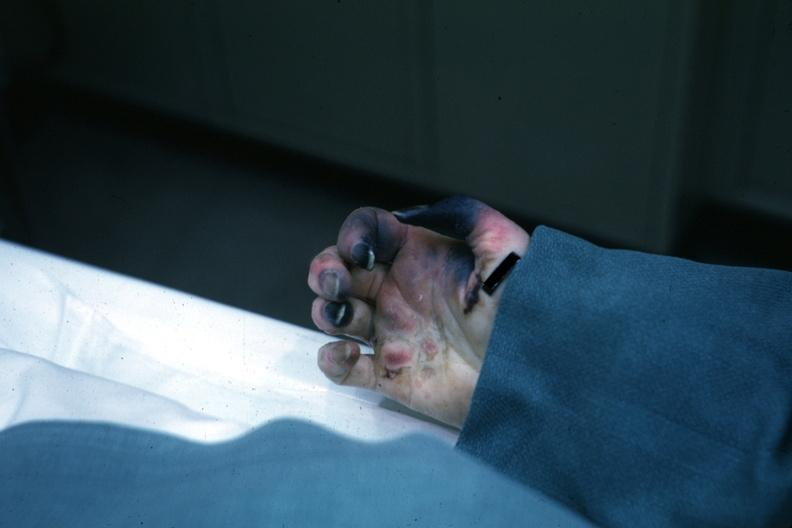does pituitary know shock vs emboli?
Answer the question using a single word or phrase. No 